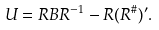<formula> <loc_0><loc_0><loc_500><loc_500>U = R B R ^ { - 1 } - R ( R ^ { \# } ) ^ { \prime } .</formula> 